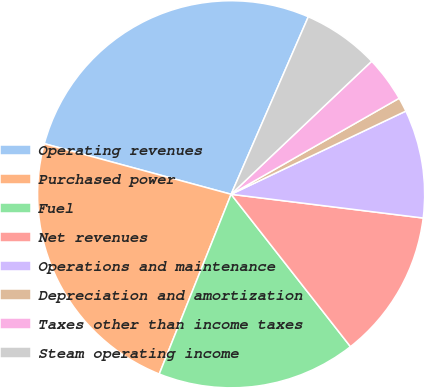<chart> <loc_0><loc_0><loc_500><loc_500><pie_chart><fcel>Operating revenues<fcel>Purchased power<fcel>Fuel<fcel>Net revenues<fcel>Operations and maintenance<fcel>Depreciation and amortization<fcel>Taxes other than income taxes<fcel>Steam operating income<nl><fcel>27.32%<fcel>23.16%<fcel>16.63%<fcel>12.47%<fcel>9.03%<fcel>1.19%<fcel>3.8%<fcel>6.41%<nl></chart> 